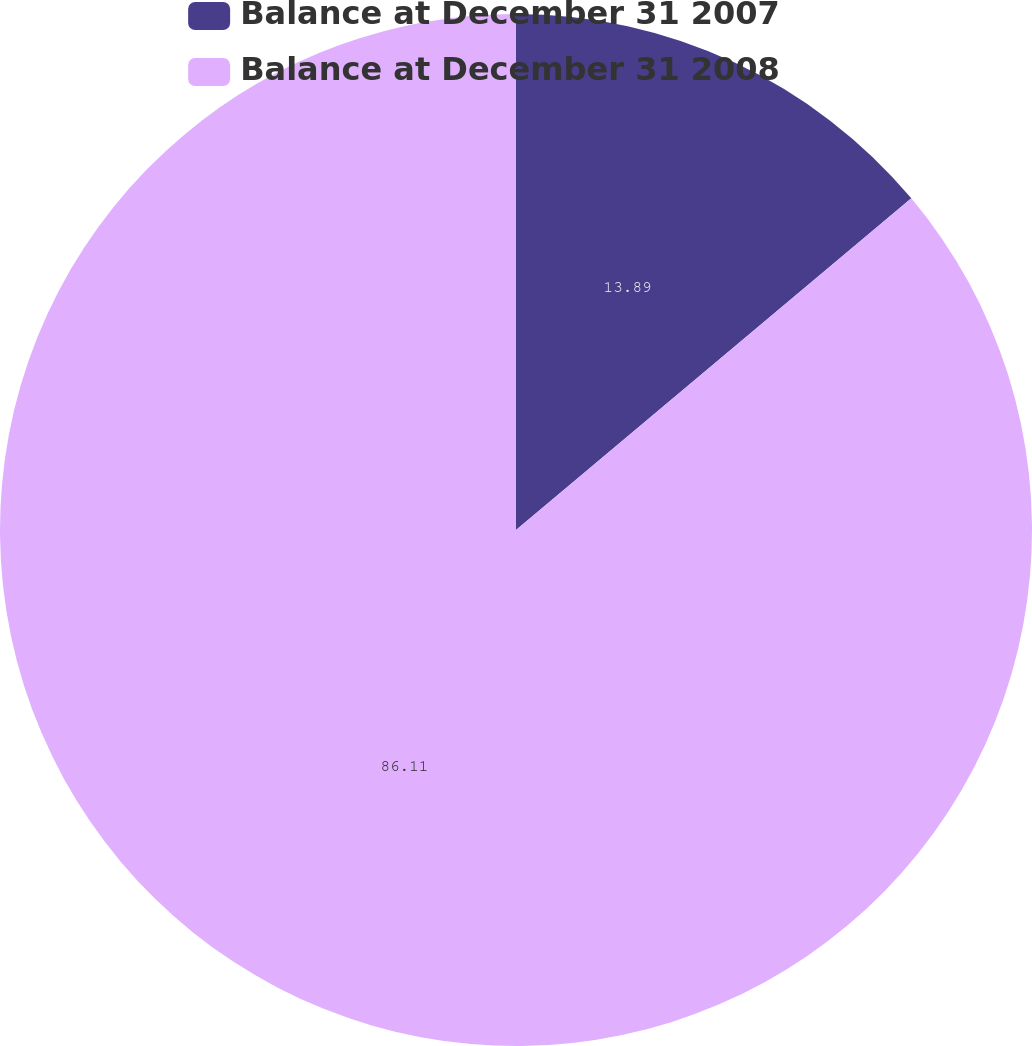Convert chart. <chart><loc_0><loc_0><loc_500><loc_500><pie_chart><fcel>Balance at December 31 2007<fcel>Balance at December 31 2008<nl><fcel>13.89%<fcel>86.11%<nl></chart> 